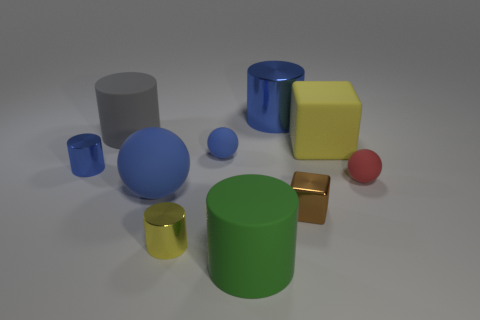Subtract all purple cylinders. Subtract all blue spheres. How many cylinders are left? 5 Subtract all green spheres. How many purple cubes are left? 0 Add 6 blues. How many big things exist? 0 Subtract all big gray matte objects. Subtract all small metal cubes. How many objects are left? 8 Add 4 gray rubber objects. How many gray rubber objects are left? 5 Add 2 large shiny cylinders. How many large shiny cylinders exist? 3 Subtract all blue cylinders. How many cylinders are left? 3 Subtract all rubber cylinders. How many cylinders are left? 3 Subtract 1 yellow cylinders. How many objects are left? 9 Subtract all blue cylinders. How many were subtracted if there are1blue cylinders left? 1 